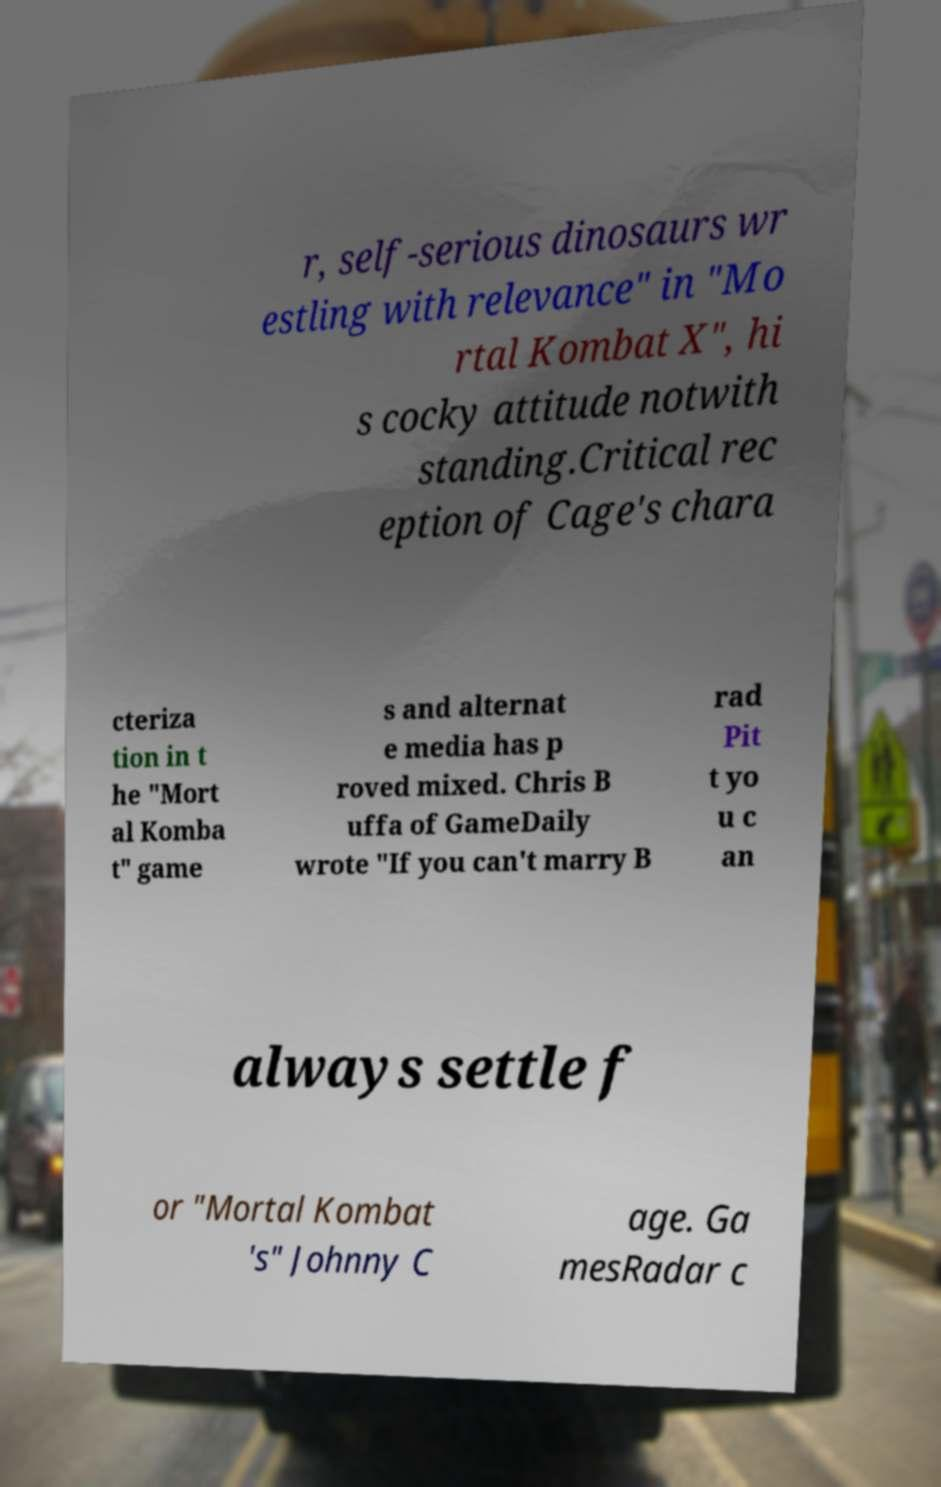What messages or text are displayed in this image? I need them in a readable, typed format. r, self-serious dinosaurs wr estling with relevance" in "Mo rtal Kombat X", hi s cocky attitude notwith standing.Critical rec eption of Cage's chara cteriza tion in t he "Mort al Komba t" game s and alternat e media has p roved mixed. Chris B uffa of GameDaily wrote "If you can't marry B rad Pit t yo u c an always settle f or "Mortal Kombat 's" Johnny C age. Ga mesRadar c 